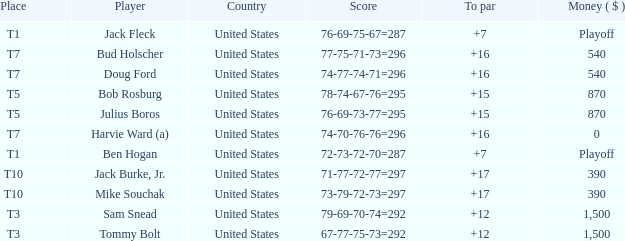Could you parse the entire table? {'header': ['Place', 'Player', 'Country', 'Score', 'To par', 'Money ( $ )'], 'rows': [['T1', 'Jack Fleck', 'United States', '76-69-75-67=287', '+7', 'Playoff'], ['T7', 'Bud Holscher', 'United States', '77-75-71-73=296', '+16', '540'], ['T7', 'Doug Ford', 'United States', '74-77-74-71=296', '+16', '540'], ['T5', 'Bob Rosburg', 'United States', '78-74-67-76=295', '+15', '870'], ['T5', 'Julius Boros', 'United States', '76-69-73-77=295', '+15', '870'], ['T7', 'Harvie Ward (a)', 'United States', '74-70-76-76=296', '+16', '0'], ['T1', 'Ben Hogan', 'United States', '72-73-72-70=287', '+7', 'Playoff'], ['T10', 'Jack Burke, Jr.', 'United States', '71-77-72-77=297', '+17', '390'], ['T10', 'Mike Souchak', 'United States', '73-79-72-73=297', '+17', '390'], ['T3', 'Sam Snead', 'United States', '79-69-70-74=292', '+12', '1,500'], ['T3', 'Tommy Bolt', 'United States', '67-77-75-73=292', '+12', '1,500']]} What is the total of all to par with player Bob Rosburg? 15.0. 